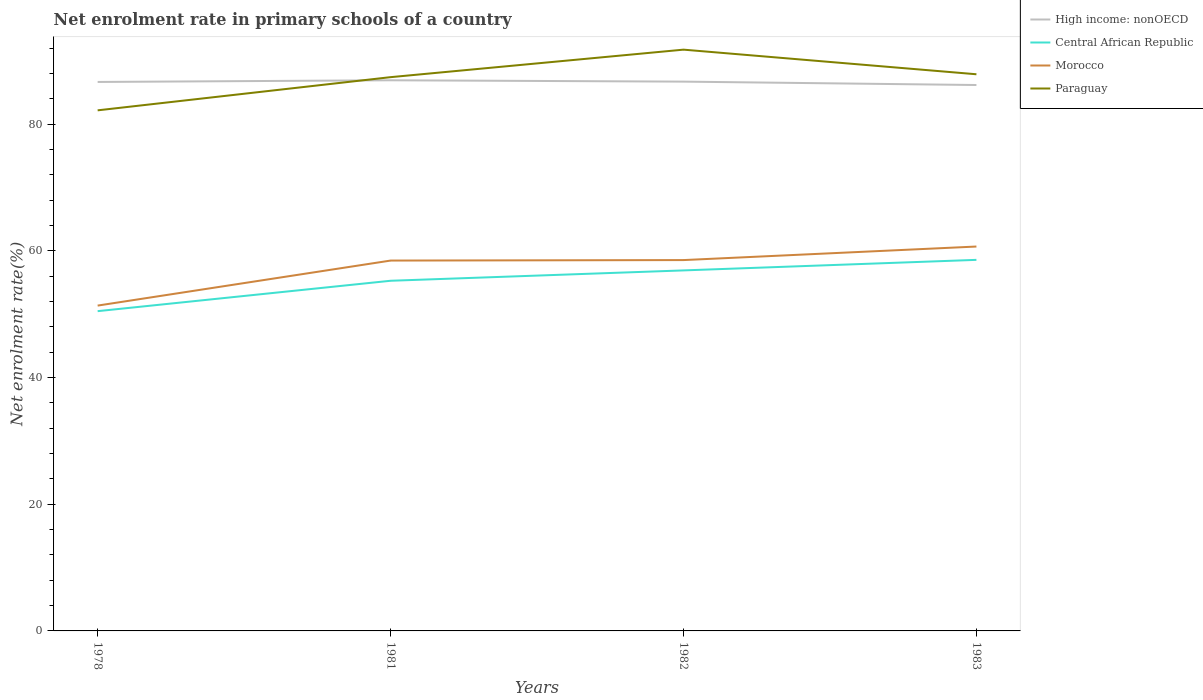How many different coloured lines are there?
Offer a terse response. 4. Does the line corresponding to Morocco intersect with the line corresponding to High income: nonOECD?
Ensure brevity in your answer.  No. Is the number of lines equal to the number of legend labels?
Make the answer very short. Yes. Across all years, what is the maximum net enrolment rate in primary schools in Morocco?
Provide a succinct answer. 51.36. In which year was the net enrolment rate in primary schools in Central African Republic maximum?
Your answer should be very brief. 1978. What is the total net enrolment rate in primary schools in High income: nonOECD in the graph?
Make the answer very short. -0.26. What is the difference between the highest and the second highest net enrolment rate in primary schools in Paraguay?
Your answer should be very brief. 9.58. What is the difference between the highest and the lowest net enrolment rate in primary schools in Central African Republic?
Offer a very short reply. 2. Is the net enrolment rate in primary schools in High income: nonOECD strictly greater than the net enrolment rate in primary schools in Paraguay over the years?
Give a very brief answer. No. What is the difference between two consecutive major ticks on the Y-axis?
Provide a succinct answer. 20. How are the legend labels stacked?
Ensure brevity in your answer.  Vertical. What is the title of the graph?
Ensure brevity in your answer.  Net enrolment rate in primary schools of a country. Does "Moldova" appear as one of the legend labels in the graph?
Your answer should be very brief. No. What is the label or title of the Y-axis?
Your answer should be compact. Net enrolment rate(%). What is the Net enrolment rate(%) of High income: nonOECD in 1978?
Give a very brief answer. 86.66. What is the Net enrolment rate(%) in Central African Republic in 1978?
Your answer should be very brief. 50.48. What is the Net enrolment rate(%) in Morocco in 1978?
Your response must be concise. 51.36. What is the Net enrolment rate(%) of Paraguay in 1978?
Offer a very short reply. 82.18. What is the Net enrolment rate(%) of High income: nonOECD in 1981?
Make the answer very short. 86.92. What is the Net enrolment rate(%) of Central African Republic in 1981?
Offer a very short reply. 55.27. What is the Net enrolment rate(%) in Morocco in 1981?
Give a very brief answer. 58.46. What is the Net enrolment rate(%) of Paraguay in 1981?
Give a very brief answer. 87.41. What is the Net enrolment rate(%) of High income: nonOECD in 1982?
Offer a terse response. 86.71. What is the Net enrolment rate(%) in Central African Republic in 1982?
Provide a succinct answer. 56.91. What is the Net enrolment rate(%) in Morocco in 1982?
Offer a terse response. 58.54. What is the Net enrolment rate(%) of Paraguay in 1982?
Give a very brief answer. 91.76. What is the Net enrolment rate(%) in High income: nonOECD in 1983?
Keep it short and to the point. 86.17. What is the Net enrolment rate(%) of Central African Republic in 1983?
Your response must be concise. 58.57. What is the Net enrolment rate(%) in Morocco in 1983?
Give a very brief answer. 60.68. What is the Net enrolment rate(%) of Paraguay in 1983?
Give a very brief answer. 87.87. Across all years, what is the maximum Net enrolment rate(%) of High income: nonOECD?
Provide a short and direct response. 86.92. Across all years, what is the maximum Net enrolment rate(%) in Central African Republic?
Your answer should be very brief. 58.57. Across all years, what is the maximum Net enrolment rate(%) in Morocco?
Provide a short and direct response. 60.68. Across all years, what is the maximum Net enrolment rate(%) in Paraguay?
Your answer should be compact. 91.76. Across all years, what is the minimum Net enrolment rate(%) in High income: nonOECD?
Provide a short and direct response. 86.17. Across all years, what is the minimum Net enrolment rate(%) in Central African Republic?
Provide a succinct answer. 50.48. Across all years, what is the minimum Net enrolment rate(%) in Morocco?
Your answer should be very brief. 51.36. Across all years, what is the minimum Net enrolment rate(%) in Paraguay?
Make the answer very short. 82.18. What is the total Net enrolment rate(%) of High income: nonOECD in the graph?
Your answer should be very brief. 346.46. What is the total Net enrolment rate(%) of Central African Republic in the graph?
Keep it short and to the point. 221.23. What is the total Net enrolment rate(%) in Morocco in the graph?
Your response must be concise. 229.03. What is the total Net enrolment rate(%) of Paraguay in the graph?
Provide a succinct answer. 349.22. What is the difference between the Net enrolment rate(%) of High income: nonOECD in 1978 and that in 1981?
Your answer should be compact. -0.26. What is the difference between the Net enrolment rate(%) in Central African Republic in 1978 and that in 1981?
Your answer should be very brief. -4.8. What is the difference between the Net enrolment rate(%) in Morocco in 1978 and that in 1981?
Make the answer very short. -7.11. What is the difference between the Net enrolment rate(%) in Paraguay in 1978 and that in 1981?
Your answer should be compact. -5.24. What is the difference between the Net enrolment rate(%) in High income: nonOECD in 1978 and that in 1982?
Your response must be concise. -0.05. What is the difference between the Net enrolment rate(%) of Central African Republic in 1978 and that in 1982?
Your answer should be very brief. -6.43. What is the difference between the Net enrolment rate(%) of Morocco in 1978 and that in 1982?
Your answer should be compact. -7.18. What is the difference between the Net enrolment rate(%) in Paraguay in 1978 and that in 1982?
Your answer should be compact. -9.58. What is the difference between the Net enrolment rate(%) of High income: nonOECD in 1978 and that in 1983?
Give a very brief answer. 0.48. What is the difference between the Net enrolment rate(%) of Central African Republic in 1978 and that in 1983?
Give a very brief answer. -8.1. What is the difference between the Net enrolment rate(%) in Morocco in 1978 and that in 1983?
Keep it short and to the point. -9.32. What is the difference between the Net enrolment rate(%) of Paraguay in 1978 and that in 1983?
Ensure brevity in your answer.  -5.69. What is the difference between the Net enrolment rate(%) of High income: nonOECD in 1981 and that in 1982?
Your answer should be very brief. 0.21. What is the difference between the Net enrolment rate(%) in Central African Republic in 1981 and that in 1982?
Keep it short and to the point. -1.64. What is the difference between the Net enrolment rate(%) in Morocco in 1981 and that in 1982?
Your response must be concise. -0.08. What is the difference between the Net enrolment rate(%) of Paraguay in 1981 and that in 1982?
Give a very brief answer. -4.34. What is the difference between the Net enrolment rate(%) of High income: nonOECD in 1981 and that in 1983?
Offer a terse response. 0.75. What is the difference between the Net enrolment rate(%) of Central African Republic in 1981 and that in 1983?
Your response must be concise. -3.3. What is the difference between the Net enrolment rate(%) in Morocco in 1981 and that in 1983?
Offer a terse response. -2.21. What is the difference between the Net enrolment rate(%) in Paraguay in 1981 and that in 1983?
Your answer should be compact. -0.46. What is the difference between the Net enrolment rate(%) of High income: nonOECD in 1982 and that in 1983?
Ensure brevity in your answer.  0.54. What is the difference between the Net enrolment rate(%) in Central African Republic in 1982 and that in 1983?
Provide a succinct answer. -1.67. What is the difference between the Net enrolment rate(%) of Morocco in 1982 and that in 1983?
Keep it short and to the point. -2.14. What is the difference between the Net enrolment rate(%) of Paraguay in 1982 and that in 1983?
Provide a short and direct response. 3.89. What is the difference between the Net enrolment rate(%) in High income: nonOECD in 1978 and the Net enrolment rate(%) in Central African Republic in 1981?
Provide a short and direct response. 31.38. What is the difference between the Net enrolment rate(%) of High income: nonOECD in 1978 and the Net enrolment rate(%) of Morocco in 1981?
Keep it short and to the point. 28.2. What is the difference between the Net enrolment rate(%) in High income: nonOECD in 1978 and the Net enrolment rate(%) in Paraguay in 1981?
Your answer should be compact. -0.76. What is the difference between the Net enrolment rate(%) of Central African Republic in 1978 and the Net enrolment rate(%) of Morocco in 1981?
Make the answer very short. -7.99. What is the difference between the Net enrolment rate(%) in Central African Republic in 1978 and the Net enrolment rate(%) in Paraguay in 1981?
Your answer should be compact. -36.94. What is the difference between the Net enrolment rate(%) in Morocco in 1978 and the Net enrolment rate(%) in Paraguay in 1981?
Your answer should be very brief. -36.06. What is the difference between the Net enrolment rate(%) in High income: nonOECD in 1978 and the Net enrolment rate(%) in Central African Republic in 1982?
Ensure brevity in your answer.  29.75. What is the difference between the Net enrolment rate(%) in High income: nonOECD in 1978 and the Net enrolment rate(%) in Morocco in 1982?
Your answer should be compact. 28.12. What is the difference between the Net enrolment rate(%) in High income: nonOECD in 1978 and the Net enrolment rate(%) in Paraguay in 1982?
Your answer should be very brief. -5.1. What is the difference between the Net enrolment rate(%) in Central African Republic in 1978 and the Net enrolment rate(%) in Morocco in 1982?
Ensure brevity in your answer.  -8.06. What is the difference between the Net enrolment rate(%) of Central African Republic in 1978 and the Net enrolment rate(%) of Paraguay in 1982?
Provide a short and direct response. -41.28. What is the difference between the Net enrolment rate(%) in Morocco in 1978 and the Net enrolment rate(%) in Paraguay in 1982?
Your response must be concise. -40.4. What is the difference between the Net enrolment rate(%) of High income: nonOECD in 1978 and the Net enrolment rate(%) of Central African Republic in 1983?
Offer a very short reply. 28.08. What is the difference between the Net enrolment rate(%) of High income: nonOECD in 1978 and the Net enrolment rate(%) of Morocco in 1983?
Keep it short and to the point. 25.98. What is the difference between the Net enrolment rate(%) of High income: nonOECD in 1978 and the Net enrolment rate(%) of Paraguay in 1983?
Offer a very short reply. -1.21. What is the difference between the Net enrolment rate(%) in Central African Republic in 1978 and the Net enrolment rate(%) in Morocco in 1983?
Provide a succinct answer. -10.2. What is the difference between the Net enrolment rate(%) in Central African Republic in 1978 and the Net enrolment rate(%) in Paraguay in 1983?
Offer a very short reply. -37.39. What is the difference between the Net enrolment rate(%) of Morocco in 1978 and the Net enrolment rate(%) of Paraguay in 1983?
Offer a very short reply. -36.51. What is the difference between the Net enrolment rate(%) of High income: nonOECD in 1981 and the Net enrolment rate(%) of Central African Republic in 1982?
Keep it short and to the point. 30.01. What is the difference between the Net enrolment rate(%) in High income: nonOECD in 1981 and the Net enrolment rate(%) in Morocco in 1982?
Offer a terse response. 28.38. What is the difference between the Net enrolment rate(%) in High income: nonOECD in 1981 and the Net enrolment rate(%) in Paraguay in 1982?
Your answer should be compact. -4.84. What is the difference between the Net enrolment rate(%) of Central African Republic in 1981 and the Net enrolment rate(%) of Morocco in 1982?
Provide a succinct answer. -3.26. What is the difference between the Net enrolment rate(%) of Central African Republic in 1981 and the Net enrolment rate(%) of Paraguay in 1982?
Give a very brief answer. -36.48. What is the difference between the Net enrolment rate(%) in Morocco in 1981 and the Net enrolment rate(%) in Paraguay in 1982?
Provide a short and direct response. -33.29. What is the difference between the Net enrolment rate(%) of High income: nonOECD in 1981 and the Net enrolment rate(%) of Central African Republic in 1983?
Your answer should be compact. 28.35. What is the difference between the Net enrolment rate(%) of High income: nonOECD in 1981 and the Net enrolment rate(%) of Morocco in 1983?
Keep it short and to the point. 26.24. What is the difference between the Net enrolment rate(%) in High income: nonOECD in 1981 and the Net enrolment rate(%) in Paraguay in 1983?
Your answer should be compact. -0.95. What is the difference between the Net enrolment rate(%) of Central African Republic in 1981 and the Net enrolment rate(%) of Morocco in 1983?
Keep it short and to the point. -5.4. What is the difference between the Net enrolment rate(%) of Central African Republic in 1981 and the Net enrolment rate(%) of Paraguay in 1983?
Give a very brief answer. -32.6. What is the difference between the Net enrolment rate(%) of Morocco in 1981 and the Net enrolment rate(%) of Paraguay in 1983?
Your answer should be very brief. -29.41. What is the difference between the Net enrolment rate(%) of High income: nonOECD in 1982 and the Net enrolment rate(%) of Central African Republic in 1983?
Make the answer very short. 28.14. What is the difference between the Net enrolment rate(%) of High income: nonOECD in 1982 and the Net enrolment rate(%) of Morocco in 1983?
Give a very brief answer. 26.03. What is the difference between the Net enrolment rate(%) of High income: nonOECD in 1982 and the Net enrolment rate(%) of Paraguay in 1983?
Keep it short and to the point. -1.16. What is the difference between the Net enrolment rate(%) of Central African Republic in 1982 and the Net enrolment rate(%) of Morocco in 1983?
Your answer should be compact. -3.77. What is the difference between the Net enrolment rate(%) in Central African Republic in 1982 and the Net enrolment rate(%) in Paraguay in 1983?
Offer a terse response. -30.96. What is the difference between the Net enrolment rate(%) in Morocco in 1982 and the Net enrolment rate(%) in Paraguay in 1983?
Your answer should be very brief. -29.33. What is the average Net enrolment rate(%) in High income: nonOECD per year?
Provide a short and direct response. 86.61. What is the average Net enrolment rate(%) in Central African Republic per year?
Make the answer very short. 55.31. What is the average Net enrolment rate(%) in Morocco per year?
Ensure brevity in your answer.  57.26. What is the average Net enrolment rate(%) in Paraguay per year?
Offer a terse response. 87.3. In the year 1978, what is the difference between the Net enrolment rate(%) in High income: nonOECD and Net enrolment rate(%) in Central African Republic?
Offer a terse response. 36.18. In the year 1978, what is the difference between the Net enrolment rate(%) in High income: nonOECD and Net enrolment rate(%) in Morocco?
Keep it short and to the point. 35.3. In the year 1978, what is the difference between the Net enrolment rate(%) of High income: nonOECD and Net enrolment rate(%) of Paraguay?
Provide a succinct answer. 4.48. In the year 1978, what is the difference between the Net enrolment rate(%) of Central African Republic and Net enrolment rate(%) of Morocco?
Make the answer very short. -0.88. In the year 1978, what is the difference between the Net enrolment rate(%) of Central African Republic and Net enrolment rate(%) of Paraguay?
Your response must be concise. -31.7. In the year 1978, what is the difference between the Net enrolment rate(%) in Morocco and Net enrolment rate(%) in Paraguay?
Provide a short and direct response. -30.82. In the year 1981, what is the difference between the Net enrolment rate(%) of High income: nonOECD and Net enrolment rate(%) of Central African Republic?
Your answer should be compact. 31.65. In the year 1981, what is the difference between the Net enrolment rate(%) in High income: nonOECD and Net enrolment rate(%) in Morocco?
Your response must be concise. 28.46. In the year 1981, what is the difference between the Net enrolment rate(%) in High income: nonOECD and Net enrolment rate(%) in Paraguay?
Your response must be concise. -0.49. In the year 1981, what is the difference between the Net enrolment rate(%) in Central African Republic and Net enrolment rate(%) in Morocco?
Offer a very short reply. -3.19. In the year 1981, what is the difference between the Net enrolment rate(%) of Central African Republic and Net enrolment rate(%) of Paraguay?
Make the answer very short. -32.14. In the year 1981, what is the difference between the Net enrolment rate(%) of Morocco and Net enrolment rate(%) of Paraguay?
Ensure brevity in your answer.  -28.95. In the year 1982, what is the difference between the Net enrolment rate(%) in High income: nonOECD and Net enrolment rate(%) in Central African Republic?
Your answer should be very brief. 29.8. In the year 1982, what is the difference between the Net enrolment rate(%) of High income: nonOECD and Net enrolment rate(%) of Morocco?
Provide a succinct answer. 28.17. In the year 1982, what is the difference between the Net enrolment rate(%) in High income: nonOECD and Net enrolment rate(%) in Paraguay?
Your answer should be compact. -5.05. In the year 1982, what is the difference between the Net enrolment rate(%) in Central African Republic and Net enrolment rate(%) in Morocco?
Give a very brief answer. -1.63. In the year 1982, what is the difference between the Net enrolment rate(%) of Central African Republic and Net enrolment rate(%) of Paraguay?
Provide a succinct answer. -34.85. In the year 1982, what is the difference between the Net enrolment rate(%) of Morocco and Net enrolment rate(%) of Paraguay?
Provide a succinct answer. -33.22. In the year 1983, what is the difference between the Net enrolment rate(%) in High income: nonOECD and Net enrolment rate(%) in Central African Republic?
Make the answer very short. 27.6. In the year 1983, what is the difference between the Net enrolment rate(%) in High income: nonOECD and Net enrolment rate(%) in Morocco?
Ensure brevity in your answer.  25.5. In the year 1983, what is the difference between the Net enrolment rate(%) of High income: nonOECD and Net enrolment rate(%) of Paraguay?
Your answer should be compact. -1.7. In the year 1983, what is the difference between the Net enrolment rate(%) in Central African Republic and Net enrolment rate(%) in Morocco?
Your response must be concise. -2.1. In the year 1983, what is the difference between the Net enrolment rate(%) of Central African Republic and Net enrolment rate(%) of Paraguay?
Your response must be concise. -29.3. In the year 1983, what is the difference between the Net enrolment rate(%) of Morocco and Net enrolment rate(%) of Paraguay?
Keep it short and to the point. -27.19. What is the ratio of the Net enrolment rate(%) in Central African Republic in 1978 to that in 1981?
Your response must be concise. 0.91. What is the ratio of the Net enrolment rate(%) in Morocco in 1978 to that in 1981?
Offer a terse response. 0.88. What is the ratio of the Net enrolment rate(%) of Paraguay in 1978 to that in 1981?
Make the answer very short. 0.94. What is the ratio of the Net enrolment rate(%) in Central African Republic in 1978 to that in 1982?
Give a very brief answer. 0.89. What is the ratio of the Net enrolment rate(%) in Morocco in 1978 to that in 1982?
Your response must be concise. 0.88. What is the ratio of the Net enrolment rate(%) of Paraguay in 1978 to that in 1982?
Ensure brevity in your answer.  0.9. What is the ratio of the Net enrolment rate(%) of High income: nonOECD in 1978 to that in 1983?
Give a very brief answer. 1.01. What is the ratio of the Net enrolment rate(%) in Central African Republic in 1978 to that in 1983?
Offer a terse response. 0.86. What is the ratio of the Net enrolment rate(%) of Morocco in 1978 to that in 1983?
Offer a very short reply. 0.85. What is the ratio of the Net enrolment rate(%) in Paraguay in 1978 to that in 1983?
Provide a short and direct response. 0.94. What is the ratio of the Net enrolment rate(%) of High income: nonOECD in 1981 to that in 1982?
Offer a very short reply. 1. What is the ratio of the Net enrolment rate(%) of Central African Republic in 1981 to that in 1982?
Your answer should be very brief. 0.97. What is the ratio of the Net enrolment rate(%) of Paraguay in 1981 to that in 1982?
Offer a terse response. 0.95. What is the ratio of the Net enrolment rate(%) in High income: nonOECD in 1981 to that in 1983?
Offer a terse response. 1.01. What is the ratio of the Net enrolment rate(%) of Central African Republic in 1981 to that in 1983?
Give a very brief answer. 0.94. What is the ratio of the Net enrolment rate(%) in Morocco in 1981 to that in 1983?
Keep it short and to the point. 0.96. What is the ratio of the Net enrolment rate(%) of High income: nonOECD in 1982 to that in 1983?
Give a very brief answer. 1.01. What is the ratio of the Net enrolment rate(%) of Central African Republic in 1982 to that in 1983?
Your answer should be very brief. 0.97. What is the ratio of the Net enrolment rate(%) of Morocco in 1982 to that in 1983?
Ensure brevity in your answer.  0.96. What is the ratio of the Net enrolment rate(%) of Paraguay in 1982 to that in 1983?
Your response must be concise. 1.04. What is the difference between the highest and the second highest Net enrolment rate(%) of High income: nonOECD?
Provide a succinct answer. 0.21. What is the difference between the highest and the second highest Net enrolment rate(%) in Central African Republic?
Your response must be concise. 1.67. What is the difference between the highest and the second highest Net enrolment rate(%) of Morocco?
Ensure brevity in your answer.  2.14. What is the difference between the highest and the second highest Net enrolment rate(%) in Paraguay?
Offer a terse response. 3.89. What is the difference between the highest and the lowest Net enrolment rate(%) in High income: nonOECD?
Make the answer very short. 0.75. What is the difference between the highest and the lowest Net enrolment rate(%) of Central African Republic?
Keep it short and to the point. 8.1. What is the difference between the highest and the lowest Net enrolment rate(%) of Morocco?
Offer a terse response. 9.32. What is the difference between the highest and the lowest Net enrolment rate(%) in Paraguay?
Provide a succinct answer. 9.58. 